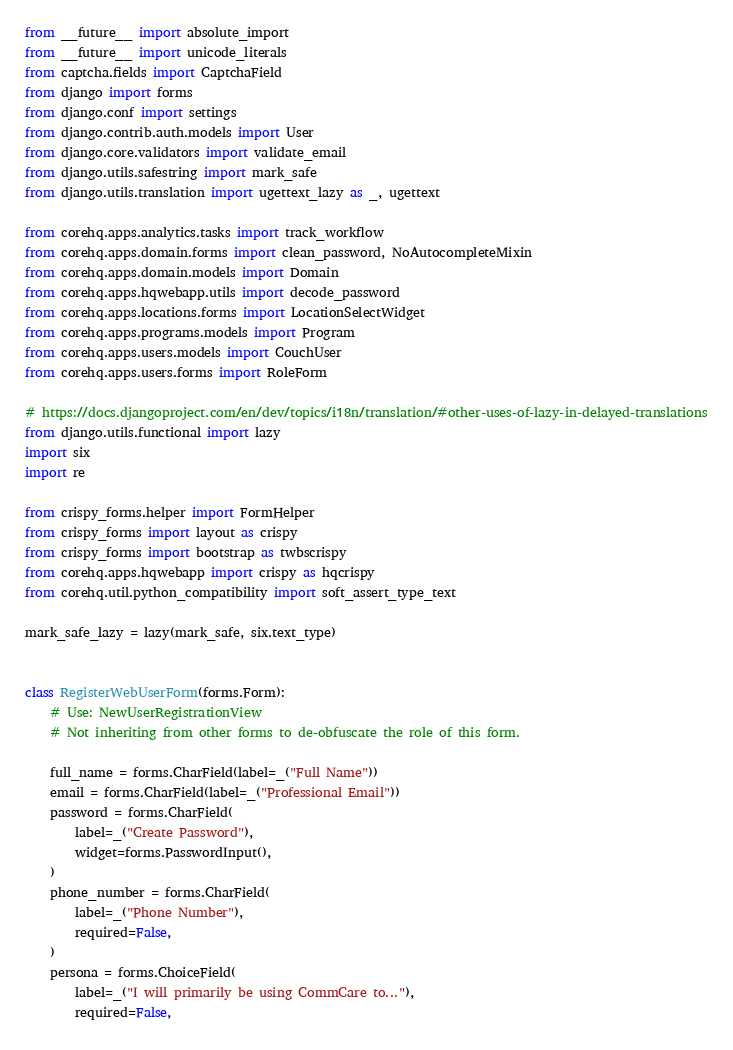<code> <loc_0><loc_0><loc_500><loc_500><_Python_>from __future__ import absolute_import
from __future__ import unicode_literals
from captcha.fields import CaptchaField
from django import forms
from django.conf import settings
from django.contrib.auth.models import User
from django.core.validators import validate_email
from django.utils.safestring import mark_safe
from django.utils.translation import ugettext_lazy as _, ugettext

from corehq.apps.analytics.tasks import track_workflow
from corehq.apps.domain.forms import clean_password, NoAutocompleteMixin
from corehq.apps.domain.models import Domain
from corehq.apps.hqwebapp.utils import decode_password
from corehq.apps.locations.forms import LocationSelectWidget
from corehq.apps.programs.models import Program
from corehq.apps.users.models import CouchUser
from corehq.apps.users.forms import RoleForm

# https://docs.djangoproject.com/en/dev/topics/i18n/translation/#other-uses-of-lazy-in-delayed-translations
from django.utils.functional import lazy
import six
import re

from crispy_forms.helper import FormHelper
from crispy_forms import layout as crispy
from crispy_forms import bootstrap as twbscrispy
from corehq.apps.hqwebapp import crispy as hqcrispy
from corehq.util.python_compatibility import soft_assert_type_text

mark_safe_lazy = lazy(mark_safe, six.text_type)


class RegisterWebUserForm(forms.Form):
    # Use: NewUserRegistrationView
    # Not inheriting from other forms to de-obfuscate the role of this form.

    full_name = forms.CharField(label=_("Full Name"))
    email = forms.CharField(label=_("Professional Email"))
    password = forms.CharField(
        label=_("Create Password"),
        widget=forms.PasswordInput(),
    )
    phone_number = forms.CharField(
        label=_("Phone Number"),
        required=False,
    )
    persona = forms.ChoiceField(
        label=_("I will primarily be using CommCare to..."),
        required=False,</code> 